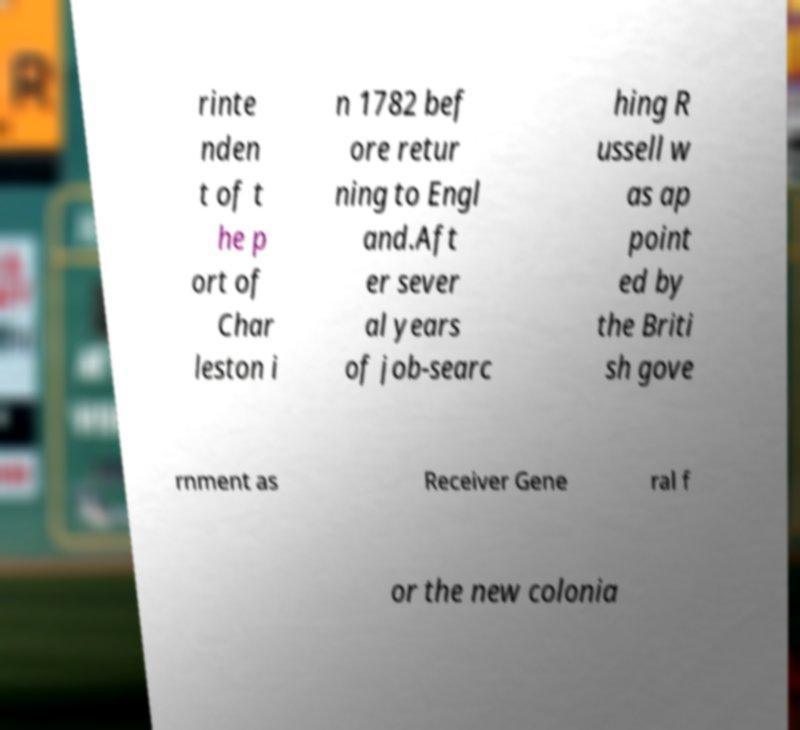Can you accurately transcribe the text from the provided image for me? rinte nden t of t he p ort of Char leston i n 1782 bef ore retur ning to Engl and.Aft er sever al years of job-searc hing R ussell w as ap point ed by the Briti sh gove rnment as Receiver Gene ral f or the new colonia 